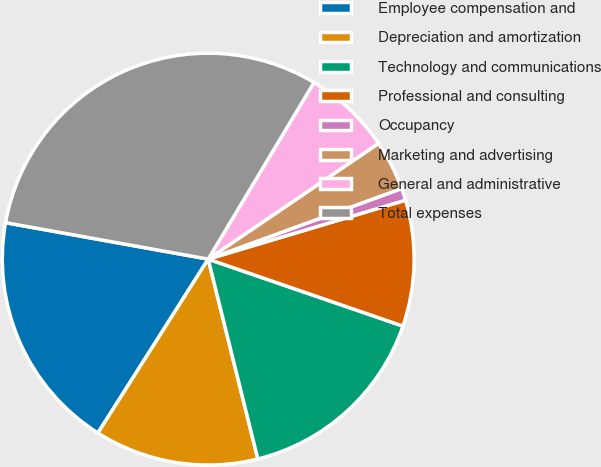Convert chart to OTSL. <chart><loc_0><loc_0><loc_500><loc_500><pie_chart><fcel>Employee compensation and<fcel>Depreciation and amortization<fcel>Technology and communications<fcel>Professional and consulting<fcel>Occupancy<fcel>Marketing and advertising<fcel>General and administrative<fcel>Total expenses<nl><fcel>18.83%<fcel>12.87%<fcel>15.85%<fcel>9.89%<fcel>0.95%<fcel>3.93%<fcel>6.91%<fcel>30.75%<nl></chart> 